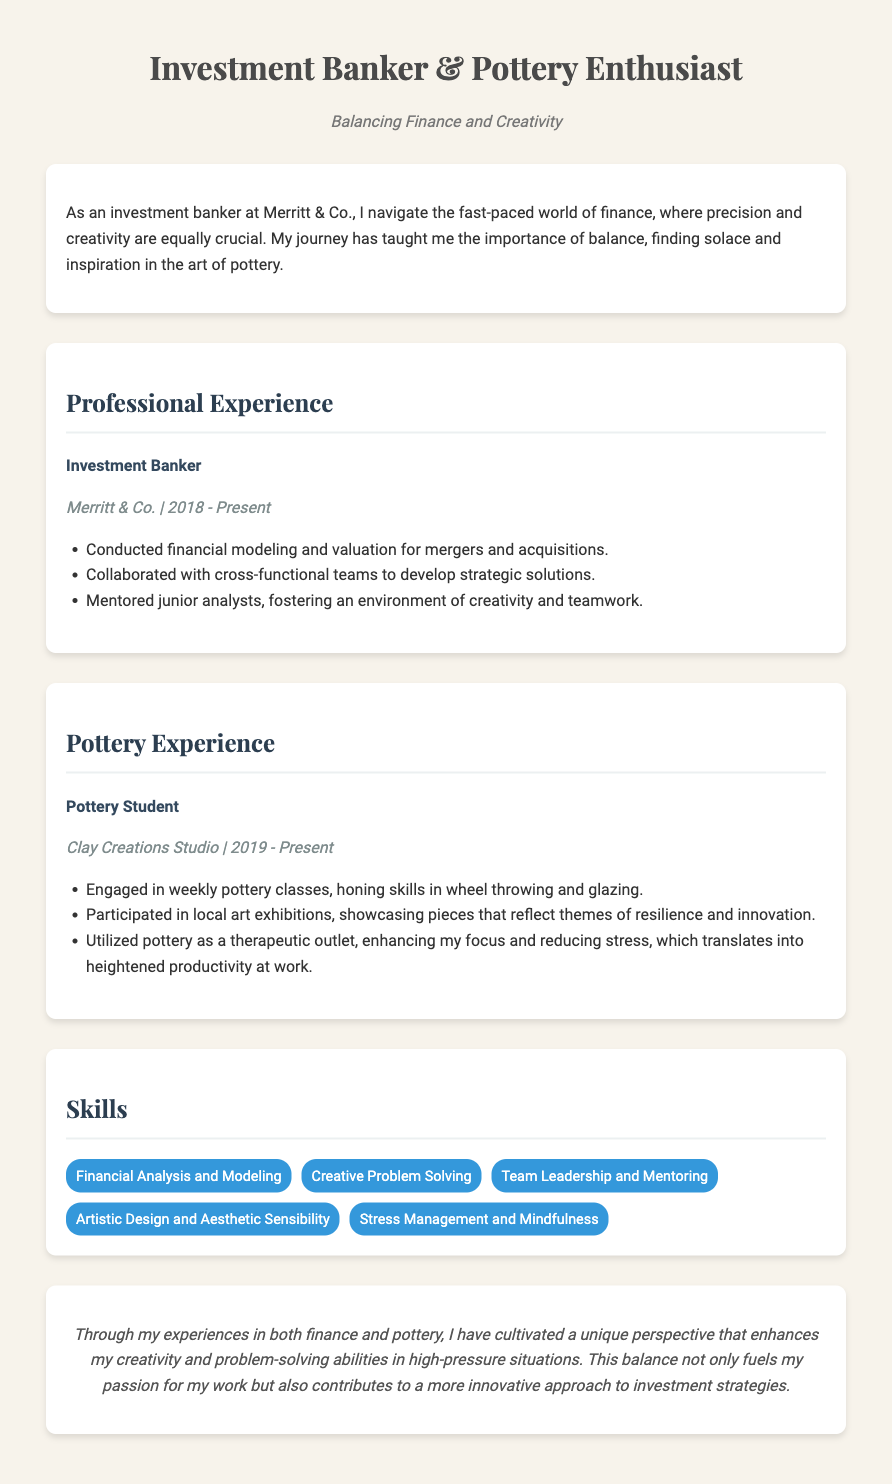What is the job title at Merritt & Co.? The job title listed in the document for the position held at Merritt & Co. is Investment Banker.
Answer: Investment Banker When did the pottery classes begin? The pottery classes started in 2019, as mentioned in the Pottery Experience section.
Answer: 2019 What skill is related to enhancing focus and reducing stress? The skill mentioned that relates to enhancing focus and reducing stress is Stress Management and Mindfulness.
Answer: Stress Management and Mindfulness What company is the investment banking position associated with? The company associated with the investment banking position is Merritt & Co.
Answer: Merritt & Co How long has the individual been working at their current job? The duration of employment at Merritt & Co. is from 2018 to the present, indicating approximately five years.
Answer: 5 years What type of artwork did the individual showcase at local art exhibitions? The individual exhibited pottery pieces that reflect themes of resilience and innovation.
Answer: Resilience and innovation How does pottery influence work productivity? It is mentioned that pottery enhances focus and reduces stress, which translates into heightened productivity at work.
Answer: Heightened productivity What is the primary focus of the personal statement? The primary focus is on balancing a demanding finance career with the therapeutic benefits of pottery.
Answer: Balance between finance and pottery 